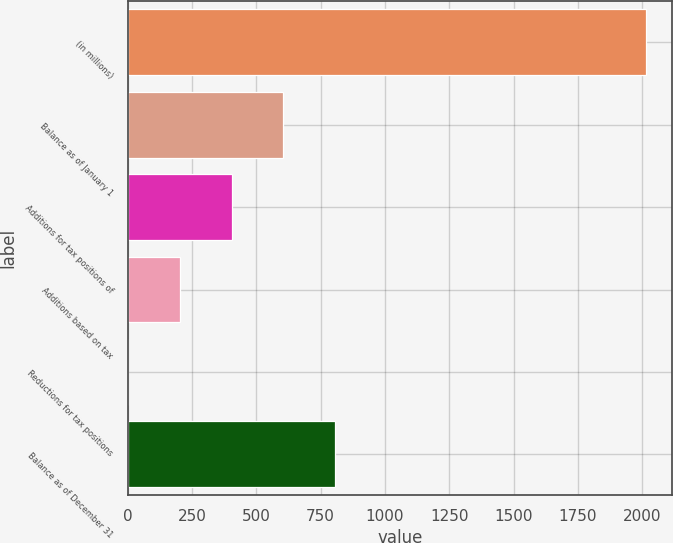Convert chart to OTSL. <chart><loc_0><loc_0><loc_500><loc_500><bar_chart><fcel>(in millions)<fcel>Balance as of January 1<fcel>Additions for tax positions of<fcel>Additions based on tax<fcel>Reductions for tax positions<fcel>Balance as of December 31<nl><fcel>2016<fcel>605.5<fcel>404<fcel>202.5<fcel>1<fcel>807<nl></chart> 